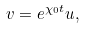<formula> <loc_0><loc_0><loc_500><loc_500>v = e ^ { \chi _ { 0 } t } u ,</formula> 